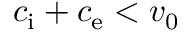Convert formula to latex. <formula><loc_0><loc_0><loc_500><loc_500>c _ { i } + c _ { e } < v _ { 0 }</formula> 